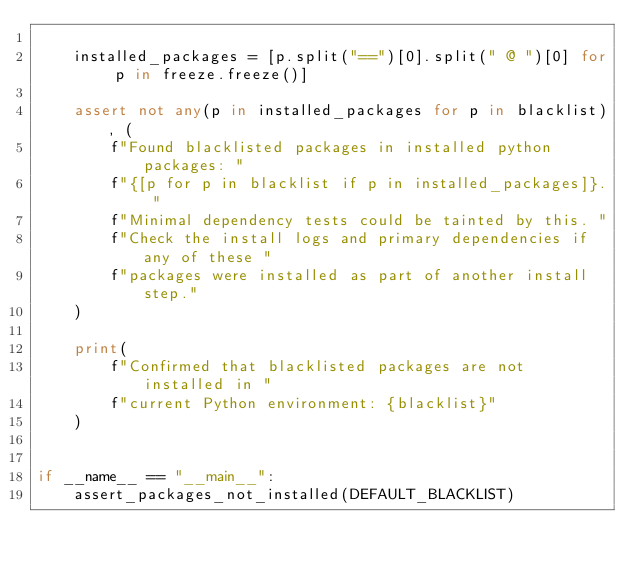Convert code to text. <code><loc_0><loc_0><loc_500><loc_500><_Python_>
    installed_packages = [p.split("==")[0].split(" @ ")[0] for p in freeze.freeze()]

    assert not any(p in installed_packages for p in blacklist), (
        f"Found blacklisted packages in installed python packages: "
        f"{[p for p in blacklist if p in installed_packages]}. "
        f"Minimal dependency tests could be tainted by this. "
        f"Check the install logs and primary dependencies if any of these "
        f"packages were installed as part of another install step."
    )

    print(
        f"Confirmed that blacklisted packages are not installed in "
        f"current Python environment: {blacklist}"
    )


if __name__ == "__main__":
    assert_packages_not_installed(DEFAULT_BLACKLIST)
</code> 